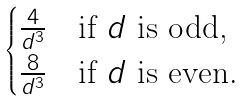<formula> <loc_0><loc_0><loc_500><loc_500>\begin{cases} \frac { 4 } { d ^ { 3 } } & \text {if $d$ is odd,} \\ \frac { 8 } { d ^ { 3 } } & \text {if $d$ is even.} \end{cases}</formula> 